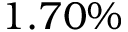Convert formula to latex. <formula><loc_0><loc_0><loc_500><loc_500>1 . 7 0 \%</formula> 